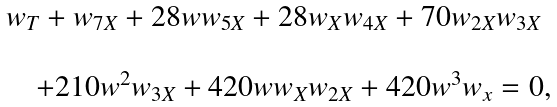<formula> <loc_0><loc_0><loc_500><loc_500>\begin{array} { l l } & w _ { T } + w _ { 7 X } + 2 8 w w _ { 5 X } + 2 8 w _ { X } w _ { 4 X } + 7 0 w _ { 2 X } w _ { 3 X } \\ \\ & \quad + 2 1 0 w ^ { 2 } w _ { 3 X } + 4 2 0 w w _ { X } w _ { 2 X } + 4 2 0 w ^ { 3 } w _ { x } = 0 , \end{array}</formula> 